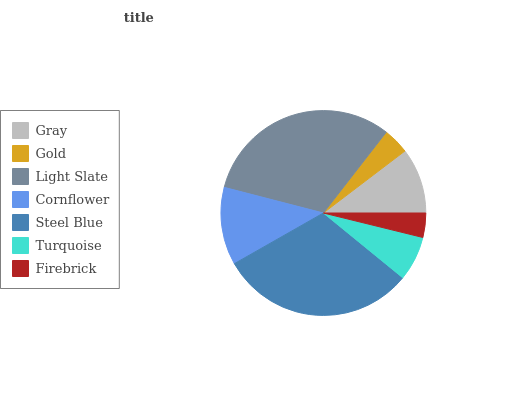Is Firebrick the minimum?
Answer yes or no. Yes. Is Light Slate the maximum?
Answer yes or no. Yes. Is Gold the minimum?
Answer yes or no. No. Is Gold the maximum?
Answer yes or no. No. Is Gray greater than Gold?
Answer yes or no. Yes. Is Gold less than Gray?
Answer yes or no. Yes. Is Gold greater than Gray?
Answer yes or no. No. Is Gray less than Gold?
Answer yes or no. No. Is Gray the high median?
Answer yes or no. Yes. Is Gray the low median?
Answer yes or no. Yes. Is Cornflower the high median?
Answer yes or no. No. Is Steel Blue the low median?
Answer yes or no. No. 